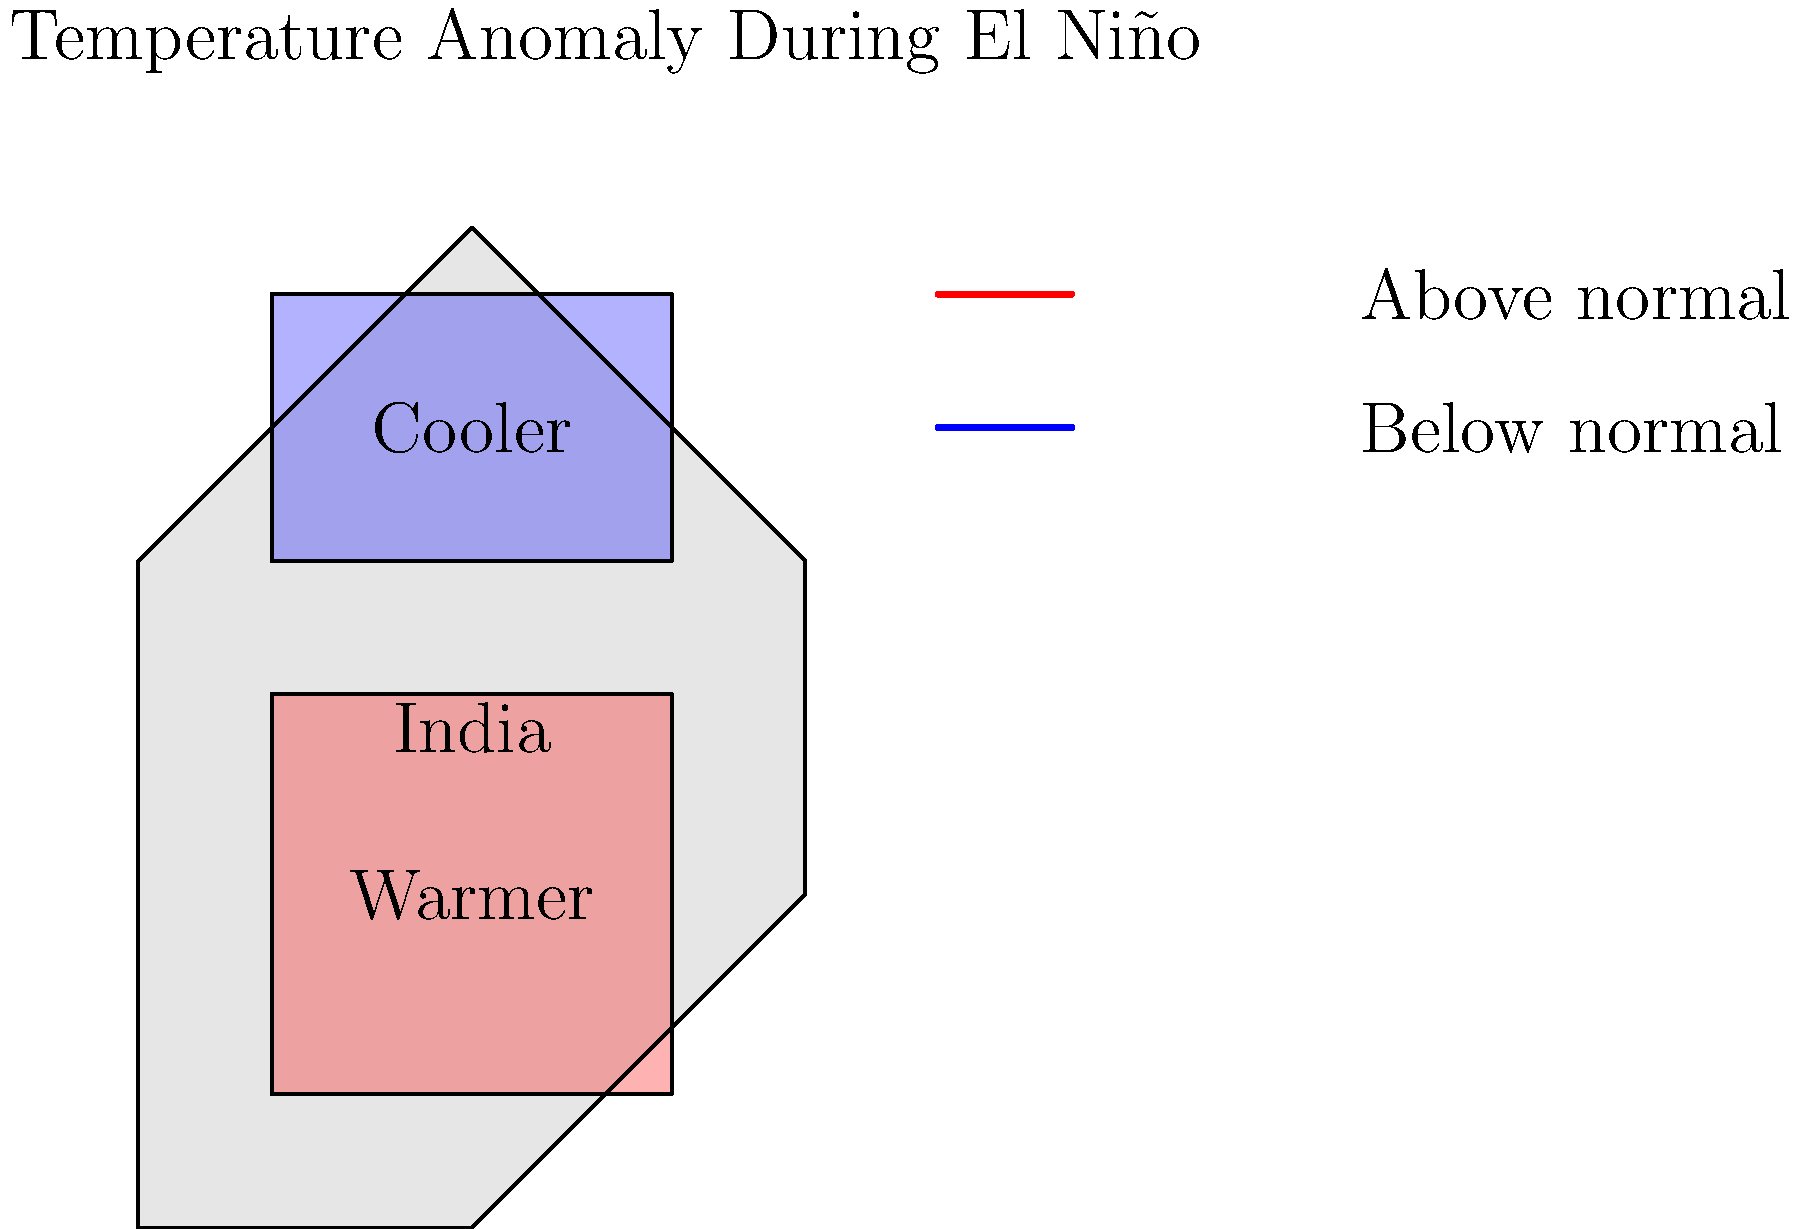Based on the temperature anomaly map of India during an El Niño event, which part of the country is likely to experience warmer than normal temperatures, and how might this affect local weather patterns? To interpret this temperature anomaly map and understand its implications:

1. Observe the map: The image shows a simplified map of India with two distinct regions colored differently.

2. Identify temperature anomalies:
   - The central and southern parts are shaded red, indicating warmer than normal temperatures.
   - The northern part is shaded blue, indicating cooler than normal temperatures.

3. Relate to El Niño:
   - El Niño typically causes warmer and drier conditions in many parts of India, especially in the central and southern regions.

4. Understand the impacts:
   - Warmer temperatures in central and southern India can lead to:
     a) Increased evaporation
     b) Reduced soil moisture
     c) Higher chances of heat waves
     d) Potential drought conditions

5. Consider local weather patterns:
   - The warmer temperatures may result in:
     a) Reduced monsoon rainfall in affected areas
     b) Changes in crop growing seasons
     c) Increased energy demand for cooling
     d) Potential health risks due to heat stress

6. Northern India implications:
   - The cooler anomaly in the north might lead to:
     a) Increased chances of fog and cold waves
     b) Possible disruptions to winter crop patterns

In conclusion, the central and southern parts of India are likely to experience warmer than normal temperatures during this El Niño event, potentially leading to drier conditions, increased risk of heat waves, and changes in local weather patterns that could affect agriculture, water resources, and public health.
Answer: Central and southern India; leading to drier conditions, increased heat waves, and altered monsoon patterns. 